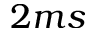Convert formula to latex. <formula><loc_0><loc_0><loc_500><loc_500>2 m s</formula> 